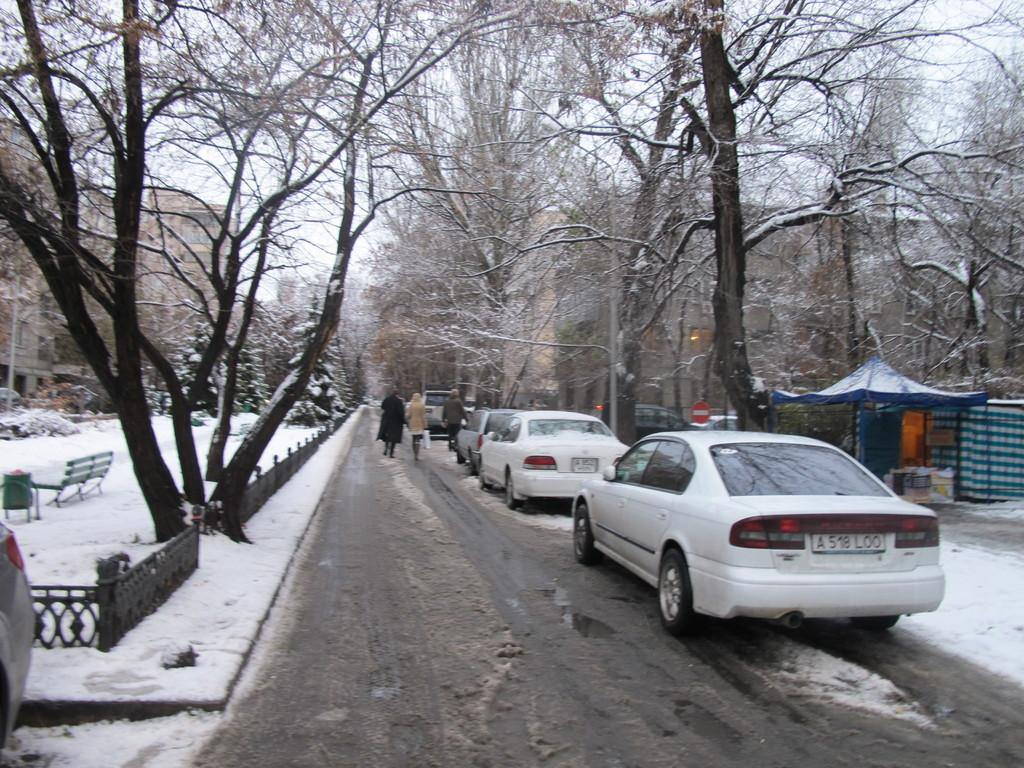What is the main feature of the image? There is a road in the image. What is happening on the road? There are vehicles on the road. Are there any people in the image? Yes, there are people standing in the image. What is the weather like in the image? There is snow visible in the image. What type of vegetation is present in the image? There are trees in the image. What type of shelter is visible in the image? There is a tent in the image. What type of seating is visible in the image? There is a bench in the image. What can be seen in the background of the image? There are buildings and the sky visible in the background of the image. What type of pencil is being used by the uncle in the image? There is no uncle or pencil present in the image. 